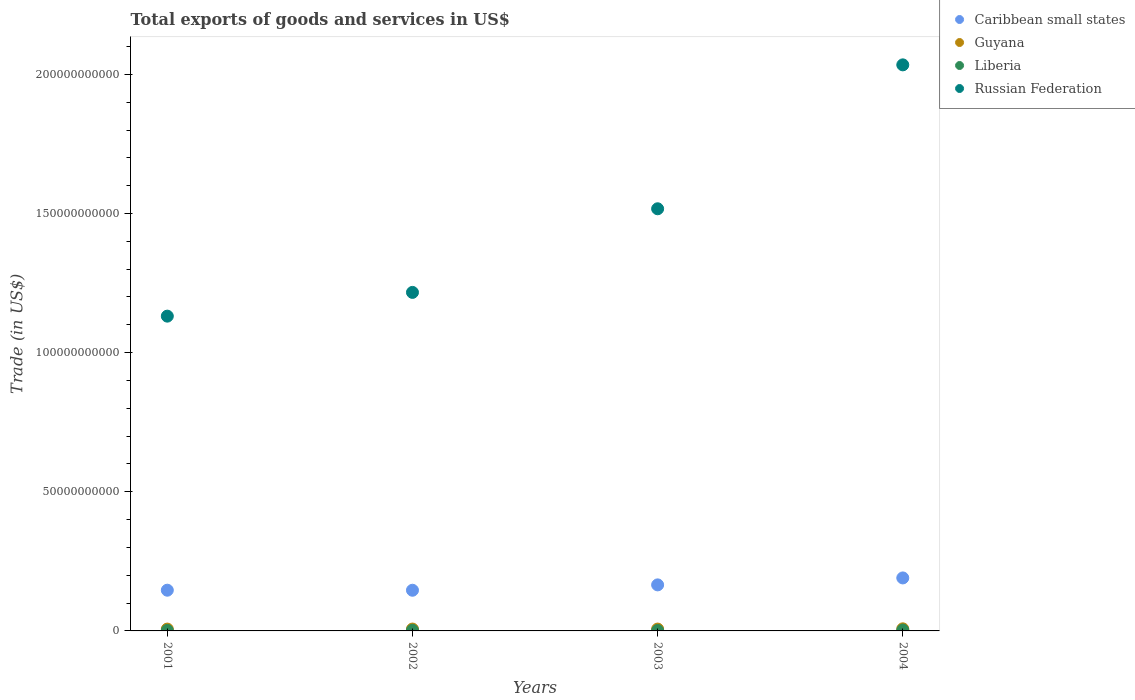What is the total exports of goods and services in Caribbean small states in 2001?
Give a very brief answer. 1.46e+1. Across all years, what is the maximum total exports of goods and services in Caribbean small states?
Your answer should be very brief. 1.90e+1. Across all years, what is the minimum total exports of goods and services in Liberia?
Give a very brief answer. 1.50e+08. In which year was the total exports of goods and services in Guyana minimum?
Your answer should be compact. 2001. What is the total total exports of goods and services in Liberia in the graph?
Your answer should be very brief. 8.78e+08. What is the difference between the total exports of goods and services in Russian Federation in 2001 and that in 2003?
Offer a terse response. -3.86e+1. What is the difference between the total exports of goods and services in Caribbean small states in 2004 and the total exports of goods and services in Liberia in 2001?
Make the answer very short. 1.89e+1. What is the average total exports of goods and services in Russian Federation per year?
Your answer should be compact. 1.47e+11. In the year 2004, what is the difference between the total exports of goods and services in Caribbean small states and total exports of goods and services in Russian Federation?
Your response must be concise. -1.84e+11. What is the ratio of the total exports of goods and services in Liberia in 2002 to that in 2004?
Your response must be concise. 0.72. Is the total exports of goods and services in Caribbean small states in 2001 less than that in 2004?
Provide a short and direct response. Yes. Is the difference between the total exports of goods and services in Caribbean small states in 2002 and 2004 greater than the difference between the total exports of goods and services in Russian Federation in 2002 and 2004?
Your answer should be very brief. Yes. What is the difference between the highest and the second highest total exports of goods and services in Liberia?
Give a very brief answer. 9.10e+07. What is the difference between the highest and the lowest total exports of goods and services in Caribbean small states?
Offer a very short reply. 4.43e+09. In how many years, is the total exports of goods and services in Russian Federation greater than the average total exports of goods and services in Russian Federation taken over all years?
Keep it short and to the point. 2. Is it the case that in every year, the sum of the total exports of goods and services in Guyana and total exports of goods and services in Russian Federation  is greater than the total exports of goods and services in Caribbean small states?
Offer a very short reply. Yes. Does the total exports of goods and services in Guyana monotonically increase over the years?
Offer a very short reply. No. Is the total exports of goods and services in Russian Federation strictly greater than the total exports of goods and services in Liberia over the years?
Offer a very short reply. Yes. Is the total exports of goods and services in Guyana strictly less than the total exports of goods and services in Caribbean small states over the years?
Offer a terse response. Yes. What is the difference between two consecutive major ticks on the Y-axis?
Give a very brief answer. 5.00e+1. Where does the legend appear in the graph?
Make the answer very short. Top right. How are the legend labels stacked?
Offer a terse response. Vertical. What is the title of the graph?
Provide a short and direct response. Total exports of goods and services in US$. What is the label or title of the Y-axis?
Give a very brief answer. Trade (in US$). What is the Trade (in US$) in Caribbean small states in 2001?
Offer a very short reply. 1.46e+1. What is the Trade (in US$) of Guyana in 2001?
Your answer should be compact. 6.61e+08. What is the Trade (in US$) of Liberia in 2001?
Keep it short and to the point. 1.77e+08. What is the Trade (in US$) in Russian Federation in 2001?
Keep it short and to the point. 1.13e+11. What is the Trade (in US$) in Caribbean small states in 2002?
Keep it short and to the point. 1.46e+1. What is the Trade (in US$) of Guyana in 2002?
Your answer should be compact. 6.70e+08. What is the Trade (in US$) of Liberia in 2002?
Keep it short and to the point. 2.30e+08. What is the Trade (in US$) in Russian Federation in 2002?
Your answer should be very brief. 1.22e+11. What is the Trade (in US$) of Caribbean small states in 2003?
Provide a succinct answer. 1.65e+1. What is the Trade (in US$) in Guyana in 2003?
Keep it short and to the point. 6.66e+08. What is the Trade (in US$) in Liberia in 2003?
Your answer should be very brief. 1.50e+08. What is the Trade (in US$) in Russian Federation in 2003?
Offer a very short reply. 1.52e+11. What is the Trade (in US$) in Caribbean small states in 2004?
Your answer should be compact. 1.90e+1. What is the Trade (in US$) in Guyana in 2004?
Your answer should be very brief. 7.53e+08. What is the Trade (in US$) in Liberia in 2004?
Ensure brevity in your answer.  3.21e+08. What is the Trade (in US$) in Russian Federation in 2004?
Make the answer very short. 2.03e+11. Across all years, what is the maximum Trade (in US$) in Caribbean small states?
Provide a short and direct response. 1.90e+1. Across all years, what is the maximum Trade (in US$) in Guyana?
Your answer should be very brief. 7.53e+08. Across all years, what is the maximum Trade (in US$) of Liberia?
Offer a very short reply. 3.21e+08. Across all years, what is the maximum Trade (in US$) in Russian Federation?
Make the answer very short. 2.03e+11. Across all years, what is the minimum Trade (in US$) in Caribbean small states?
Your answer should be compact. 1.46e+1. Across all years, what is the minimum Trade (in US$) of Guyana?
Make the answer very short. 6.61e+08. Across all years, what is the minimum Trade (in US$) in Liberia?
Keep it short and to the point. 1.50e+08. Across all years, what is the minimum Trade (in US$) of Russian Federation?
Ensure brevity in your answer.  1.13e+11. What is the total Trade (in US$) in Caribbean small states in the graph?
Give a very brief answer. 6.48e+1. What is the total Trade (in US$) of Guyana in the graph?
Provide a short and direct response. 2.75e+09. What is the total Trade (in US$) of Liberia in the graph?
Provide a succinct answer. 8.78e+08. What is the total Trade (in US$) of Russian Federation in the graph?
Offer a terse response. 5.90e+11. What is the difference between the Trade (in US$) in Caribbean small states in 2001 and that in 2002?
Your answer should be very brief. 1.66e+07. What is the difference between the Trade (in US$) in Guyana in 2001 and that in 2002?
Ensure brevity in your answer.  -8.82e+06. What is the difference between the Trade (in US$) of Liberia in 2001 and that in 2002?
Provide a short and direct response. -5.30e+07. What is the difference between the Trade (in US$) of Russian Federation in 2001 and that in 2002?
Offer a very short reply. -8.53e+09. What is the difference between the Trade (in US$) in Caribbean small states in 2001 and that in 2003?
Ensure brevity in your answer.  -1.91e+09. What is the difference between the Trade (in US$) of Guyana in 2001 and that in 2003?
Ensure brevity in your answer.  -4.93e+06. What is the difference between the Trade (in US$) in Liberia in 2001 and that in 2003?
Offer a terse response. 2.70e+07. What is the difference between the Trade (in US$) of Russian Federation in 2001 and that in 2003?
Give a very brief answer. -3.86e+1. What is the difference between the Trade (in US$) of Caribbean small states in 2001 and that in 2004?
Provide a succinct answer. -4.41e+09. What is the difference between the Trade (in US$) in Guyana in 2001 and that in 2004?
Provide a succinct answer. -9.14e+07. What is the difference between the Trade (in US$) of Liberia in 2001 and that in 2004?
Ensure brevity in your answer.  -1.44e+08. What is the difference between the Trade (in US$) in Russian Federation in 2001 and that in 2004?
Offer a terse response. -9.03e+1. What is the difference between the Trade (in US$) in Caribbean small states in 2002 and that in 2003?
Provide a short and direct response. -1.93e+09. What is the difference between the Trade (in US$) in Guyana in 2002 and that in 2003?
Offer a very short reply. 3.89e+06. What is the difference between the Trade (in US$) of Liberia in 2002 and that in 2003?
Your answer should be very brief. 8.00e+07. What is the difference between the Trade (in US$) in Russian Federation in 2002 and that in 2003?
Offer a terse response. -3.00e+1. What is the difference between the Trade (in US$) of Caribbean small states in 2002 and that in 2004?
Your response must be concise. -4.43e+09. What is the difference between the Trade (in US$) of Guyana in 2002 and that in 2004?
Your answer should be very brief. -8.26e+07. What is the difference between the Trade (in US$) of Liberia in 2002 and that in 2004?
Your answer should be very brief. -9.10e+07. What is the difference between the Trade (in US$) in Russian Federation in 2002 and that in 2004?
Give a very brief answer. -8.18e+1. What is the difference between the Trade (in US$) of Caribbean small states in 2003 and that in 2004?
Keep it short and to the point. -2.50e+09. What is the difference between the Trade (in US$) of Guyana in 2003 and that in 2004?
Your response must be concise. -8.65e+07. What is the difference between the Trade (in US$) of Liberia in 2003 and that in 2004?
Make the answer very short. -1.71e+08. What is the difference between the Trade (in US$) in Russian Federation in 2003 and that in 2004?
Keep it short and to the point. -5.17e+1. What is the difference between the Trade (in US$) of Caribbean small states in 2001 and the Trade (in US$) of Guyana in 2002?
Your response must be concise. 1.40e+1. What is the difference between the Trade (in US$) in Caribbean small states in 2001 and the Trade (in US$) in Liberia in 2002?
Ensure brevity in your answer.  1.44e+1. What is the difference between the Trade (in US$) in Caribbean small states in 2001 and the Trade (in US$) in Russian Federation in 2002?
Keep it short and to the point. -1.07e+11. What is the difference between the Trade (in US$) in Guyana in 2001 and the Trade (in US$) in Liberia in 2002?
Keep it short and to the point. 4.31e+08. What is the difference between the Trade (in US$) of Guyana in 2001 and the Trade (in US$) of Russian Federation in 2002?
Your answer should be compact. -1.21e+11. What is the difference between the Trade (in US$) in Liberia in 2001 and the Trade (in US$) in Russian Federation in 2002?
Ensure brevity in your answer.  -1.21e+11. What is the difference between the Trade (in US$) of Caribbean small states in 2001 and the Trade (in US$) of Guyana in 2003?
Provide a succinct answer. 1.40e+1. What is the difference between the Trade (in US$) in Caribbean small states in 2001 and the Trade (in US$) in Liberia in 2003?
Keep it short and to the point. 1.45e+1. What is the difference between the Trade (in US$) in Caribbean small states in 2001 and the Trade (in US$) in Russian Federation in 2003?
Offer a terse response. -1.37e+11. What is the difference between the Trade (in US$) of Guyana in 2001 and the Trade (in US$) of Liberia in 2003?
Provide a short and direct response. 5.11e+08. What is the difference between the Trade (in US$) in Guyana in 2001 and the Trade (in US$) in Russian Federation in 2003?
Provide a succinct answer. -1.51e+11. What is the difference between the Trade (in US$) of Liberia in 2001 and the Trade (in US$) of Russian Federation in 2003?
Your response must be concise. -1.52e+11. What is the difference between the Trade (in US$) of Caribbean small states in 2001 and the Trade (in US$) of Guyana in 2004?
Provide a succinct answer. 1.39e+1. What is the difference between the Trade (in US$) in Caribbean small states in 2001 and the Trade (in US$) in Liberia in 2004?
Your response must be concise. 1.43e+1. What is the difference between the Trade (in US$) of Caribbean small states in 2001 and the Trade (in US$) of Russian Federation in 2004?
Keep it short and to the point. -1.89e+11. What is the difference between the Trade (in US$) in Guyana in 2001 and the Trade (in US$) in Liberia in 2004?
Your answer should be compact. 3.40e+08. What is the difference between the Trade (in US$) of Guyana in 2001 and the Trade (in US$) of Russian Federation in 2004?
Offer a terse response. -2.03e+11. What is the difference between the Trade (in US$) of Liberia in 2001 and the Trade (in US$) of Russian Federation in 2004?
Offer a very short reply. -2.03e+11. What is the difference between the Trade (in US$) in Caribbean small states in 2002 and the Trade (in US$) in Guyana in 2003?
Your response must be concise. 1.39e+1. What is the difference between the Trade (in US$) in Caribbean small states in 2002 and the Trade (in US$) in Liberia in 2003?
Your response must be concise. 1.45e+1. What is the difference between the Trade (in US$) of Caribbean small states in 2002 and the Trade (in US$) of Russian Federation in 2003?
Keep it short and to the point. -1.37e+11. What is the difference between the Trade (in US$) of Guyana in 2002 and the Trade (in US$) of Liberia in 2003?
Ensure brevity in your answer.  5.20e+08. What is the difference between the Trade (in US$) in Guyana in 2002 and the Trade (in US$) in Russian Federation in 2003?
Ensure brevity in your answer.  -1.51e+11. What is the difference between the Trade (in US$) in Liberia in 2002 and the Trade (in US$) in Russian Federation in 2003?
Make the answer very short. -1.51e+11. What is the difference between the Trade (in US$) of Caribbean small states in 2002 and the Trade (in US$) of Guyana in 2004?
Provide a succinct answer. 1.39e+1. What is the difference between the Trade (in US$) of Caribbean small states in 2002 and the Trade (in US$) of Liberia in 2004?
Ensure brevity in your answer.  1.43e+1. What is the difference between the Trade (in US$) in Caribbean small states in 2002 and the Trade (in US$) in Russian Federation in 2004?
Provide a short and direct response. -1.89e+11. What is the difference between the Trade (in US$) in Guyana in 2002 and the Trade (in US$) in Liberia in 2004?
Your answer should be very brief. 3.49e+08. What is the difference between the Trade (in US$) in Guyana in 2002 and the Trade (in US$) in Russian Federation in 2004?
Make the answer very short. -2.03e+11. What is the difference between the Trade (in US$) of Liberia in 2002 and the Trade (in US$) of Russian Federation in 2004?
Ensure brevity in your answer.  -2.03e+11. What is the difference between the Trade (in US$) in Caribbean small states in 2003 and the Trade (in US$) in Guyana in 2004?
Ensure brevity in your answer.  1.58e+1. What is the difference between the Trade (in US$) in Caribbean small states in 2003 and the Trade (in US$) in Liberia in 2004?
Your answer should be very brief. 1.62e+1. What is the difference between the Trade (in US$) in Caribbean small states in 2003 and the Trade (in US$) in Russian Federation in 2004?
Keep it short and to the point. -1.87e+11. What is the difference between the Trade (in US$) of Guyana in 2003 and the Trade (in US$) of Liberia in 2004?
Make the answer very short. 3.45e+08. What is the difference between the Trade (in US$) of Guyana in 2003 and the Trade (in US$) of Russian Federation in 2004?
Make the answer very short. -2.03e+11. What is the difference between the Trade (in US$) of Liberia in 2003 and the Trade (in US$) of Russian Federation in 2004?
Your answer should be very brief. -2.03e+11. What is the average Trade (in US$) in Caribbean small states per year?
Your answer should be very brief. 1.62e+1. What is the average Trade (in US$) in Guyana per year?
Provide a short and direct response. 6.88e+08. What is the average Trade (in US$) of Liberia per year?
Your response must be concise. 2.20e+08. What is the average Trade (in US$) in Russian Federation per year?
Provide a short and direct response. 1.47e+11. In the year 2001, what is the difference between the Trade (in US$) in Caribbean small states and Trade (in US$) in Guyana?
Keep it short and to the point. 1.40e+1. In the year 2001, what is the difference between the Trade (in US$) in Caribbean small states and Trade (in US$) in Liberia?
Make the answer very short. 1.45e+1. In the year 2001, what is the difference between the Trade (in US$) of Caribbean small states and Trade (in US$) of Russian Federation?
Your answer should be compact. -9.85e+1. In the year 2001, what is the difference between the Trade (in US$) in Guyana and Trade (in US$) in Liberia?
Offer a terse response. 4.84e+08. In the year 2001, what is the difference between the Trade (in US$) of Guyana and Trade (in US$) of Russian Federation?
Give a very brief answer. -1.12e+11. In the year 2001, what is the difference between the Trade (in US$) of Liberia and Trade (in US$) of Russian Federation?
Make the answer very short. -1.13e+11. In the year 2002, what is the difference between the Trade (in US$) in Caribbean small states and Trade (in US$) in Guyana?
Give a very brief answer. 1.39e+1. In the year 2002, what is the difference between the Trade (in US$) of Caribbean small states and Trade (in US$) of Liberia?
Offer a very short reply. 1.44e+1. In the year 2002, what is the difference between the Trade (in US$) of Caribbean small states and Trade (in US$) of Russian Federation?
Your answer should be compact. -1.07e+11. In the year 2002, what is the difference between the Trade (in US$) in Guyana and Trade (in US$) in Liberia?
Your response must be concise. 4.40e+08. In the year 2002, what is the difference between the Trade (in US$) of Guyana and Trade (in US$) of Russian Federation?
Offer a terse response. -1.21e+11. In the year 2002, what is the difference between the Trade (in US$) of Liberia and Trade (in US$) of Russian Federation?
Provide a succinct answer. -1.21e+11. In the year 2003, what is the difference between the Trade (in US$) in Caribbean small states and Trade (in US$) in Guyana?
Provide a short and direct response. 1.59e+1. In the year 2003, what is the difference between the Trade (in US$) in Caribbean small states and Trade (in US$) in Liberia?
Give a very brief answer. 1.64e+1. In the year 2003, what is the difference between the Trade (in US$) of Caribbean small states and Trade (in US$) of Russian Federation?
Provide a short and direct response. -1.35e+11. In the year 2003, what is the difference between the Trade (in US$) of Guyana and Trade (in US$) of Liberia?
Offer a terse response. 5.16e+08. In the year 2003, what is the difference between the Trade (in US$) in Guyana and Trade (in US$) in Russian Federation?
Your answer should be compact. -1.51e+11. In the year 2003, what is the difference between the Trade (in US$) in Liberia and Trade (in US$) in Russian Federation?
Provide a succinct answer. -1.52e+11. In the year 2004, what is the difference between the Trade (in US$) in Caribbean small states and Trade (in US$) in Guyana?
Provide a short and direct response. 1.83e+1. In the year 2004, what is the difference between the Trade (in US$) in Caribbean small states and Trade (in US$) in Liberia?
Offer a terse response. 1.87e+1. In the year 2004, what is the difference between the Trade (in US$) of Caribbean small states and Trade (in US$) of Russian Federation?
Offer a very short reply. -1.84e+11. In the year 2004, what is the difference between the Trade (in US$) in Guyana and Trade (in US$) in Liberia?
Give a very brief answer. 4.32e+08. In the year 2004, what is the difference between the Trade (in US$) in Guyana and Trade (in US$) in Russian Federation?
Offer a terse response. -2.03e+11. In the year 2004, what is the difference between the Trade (in US$) in Liberia and Trade (in US$) in Russian Federation?
Provide a succinct answer. -2.03e+11. What is the ratio of the Trade (in US$) of Guyana in 2001 to that in 2002?
Make the answer very short. 0.99. What is the ratio of the Trade (in US$) of Liberia in 2001 to that in 2002?
Give a very brief answer. 0.77. What is the ratio of the Trade (in US$) of Russian Federation in 2001 to that in 2002?
Make the answer very short. 0.93. What is the ratio of the Trade (in US$) of Caribbean small states in 2001 to that in 2003?
Ensure brevity in your answer.  0.88. What is the ratio of the Trade (in US$) in Guyana in 2001 to that in 2003?
Provide a short and direct response. 0.99. What is the ratio of the Trade (in US$) of Liberia in 2001 to that in 2003?
Offer a terse response. 1.18. What is the ratio of the Trade (in US$) of Russian Federation in 2001 to that in 2003?
Your answer should be compact. 0.75. What is the ratio of the Trade (in US$) in Caribbean small states in 2001 to that in 2004?
Your response must be concise. 0.77. What is the ratio of the Trade (in US$) in Guyana in 2001 to that in 2004?
Make the answer very short. 0.88. What is the ratio of the Trade (in US$) in Liberia in 2001 to that in 2004?
Your response must be concise. 0.55. What is the ratio of the Trade (in US$) in Russian Federation in 2001 to that in 2004?
Ensure brevity in your answer.  0.56. What is the ratio of the Trade (in US$) of Caribbean small states in 2002 to that in 2003?
Give a very brief answer. 0.88. What is the ratio of the Trade (in US$) in Guyana in 2002 to that in 2003?
Make the answer very short. 1.01. What is the ratio of the Trade (in US$) of Liberia in 2002 to that in 2003?
Ensure brevity in your answer.  1.53. What is the ratio of the Trade (in US$) of Russian Federation in 2002 to that in 2003?
Make the answer very short. 0.8. What is the ratio of the Trade (in US$) of Caribbean small states in 2002 to that in 2004?
Your answer should be very brief. 0.77. What is the ratio of the Trade (in US$) in Guyana in 2002 to that in 2004?
Keep it short and to the point. 0.89. What is the ratio of the Trade (in US$) in Liberia in 2002 to that in 2004?
Ensure brevity in your answer.  0.72. What is the ratio of the Trade (in US$) of Russian Federation in 2002 to that in 2004?
Offer a terse response. 0.6. What is the ratio of the Trade (in US$) of Caribbean small states in 2003 to that in 2004?
Your answer should be compact. 0.87. What is the ratio of the Trade (in US$) of Guyana in 2003 to that in 2004?
Provide a succinct answer. 0.89. What is the ratio of the Trade (in US$) in Liberia in 2003 to that in 2004?
Offer a very short reply. 0.47. What is the ratio of the Trade (in US$) in Russian Federation in 2003 to that in 2004?
Your response must be concise. 0.75. What is the difference between the highest and the second highest Trade (in US$) of Caribbean small states?
Provide a short and direct response. 2.50e+09. What is the difference between the highest and the second highest Trade (in US$) of Guyana?
Your response must be concise. 8.26e+07. What is the difference between the highest and the second highest Trade (in US$) of Liberia?
Give a very brief answer. 9.10e+07. What is the difference between the highest and the second highest Trade (in US$) in Russian Federation?
Provide a short and direct response. 5.17e+1. What is the difference between the highest and the lowest Trade (in US$) of Caribbean small states?
Keep it short and to the point. 4.43e+09. What is the difference between the highest and the lowest Trade (in US$) in Guyana?
Offer a very short reply. 9.14e+07. What is the difference between the highest and the lowest Trade (in US$) of Liberia?
Give a very brief answer. 1.71e+08. What is the difference between the highest and the lowest Trade (in US$) of Russian Federation?
Give a very brief answer. 9.03e+1. 